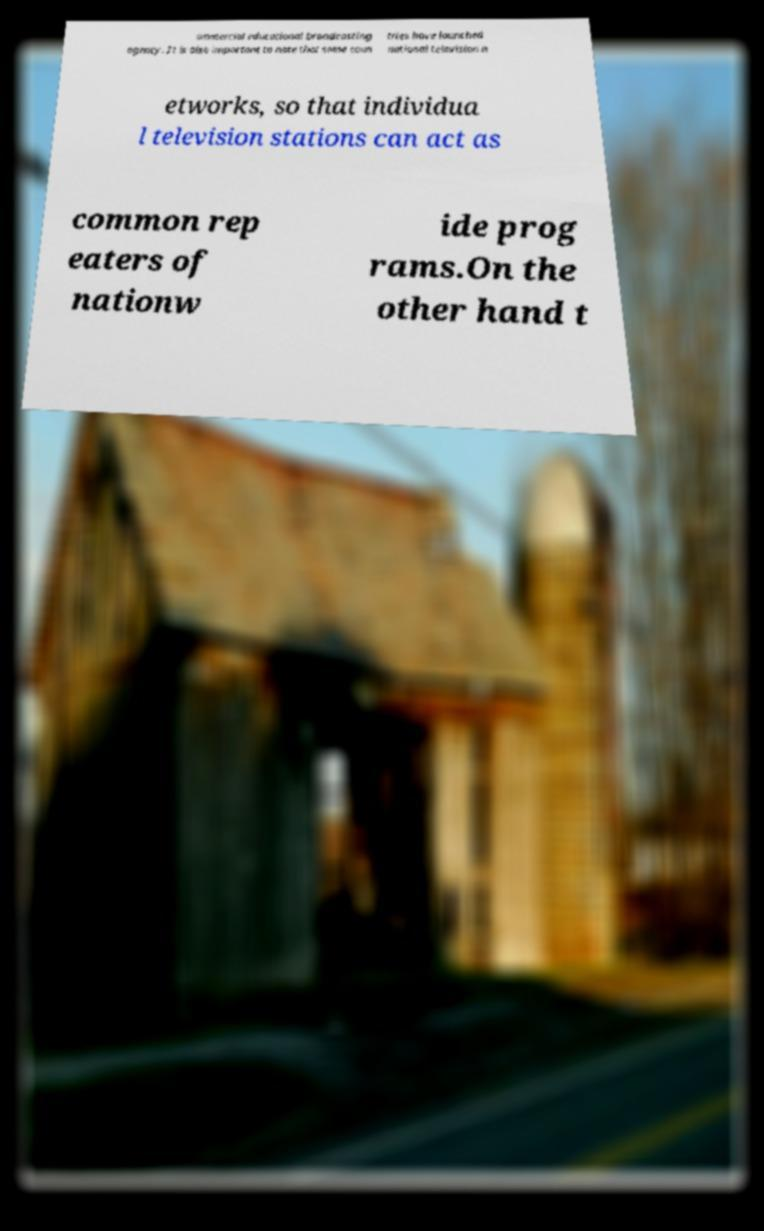Could you extract and type out the text from this image? ommercial educational broadcasting agency. It is also important to note that some coun tries have launched national television n etworks, so that individua l television stations can act as common rep eaters of nationw ide prog rams.On the other hand t 